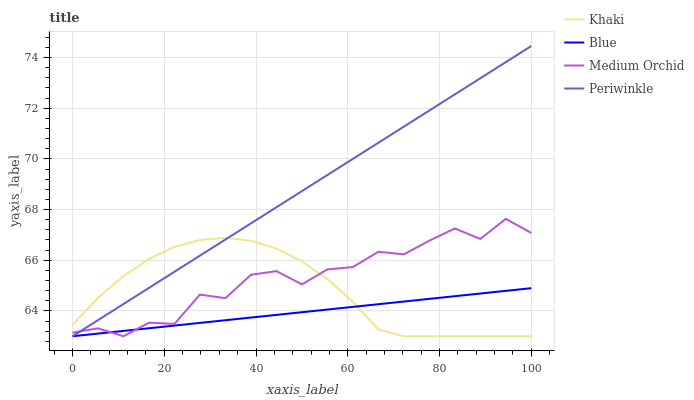Does Blue have the minimum area under the curve?
Answer yes or no. Yes. Does Periwinkle have the maximum area under the curve?
Answer yes or no. Yes. Does Medium Orchid have the minimum area under the curve?
Answer yes or no. No. Does Medium Orchid have the maximum area under the curve?
Answer yes or no. No. Is Blue the smoothest?
Answer yes or no. Yes. Is Medium Orchid the roughest?
Answer yes or no. Yes. Is Khaki the smoothest?
Answer yes or no. No. Is Khaki the roughest?
Answer yes or no. No. Does Blue have the lowest value?
Answer yes or no. Yes. Does Periwinkle have the highest value?
Answer yes or no. Yes. Does Medium Orchid have the highest value?
Answer yes or no. No. Does Khaki intersect Blue?
Answer yes or no. Yes. Is Khaki less than Blue?
Answer yes or no. No. Is Khaki greater than Blue?
Answer yes or no. No. 